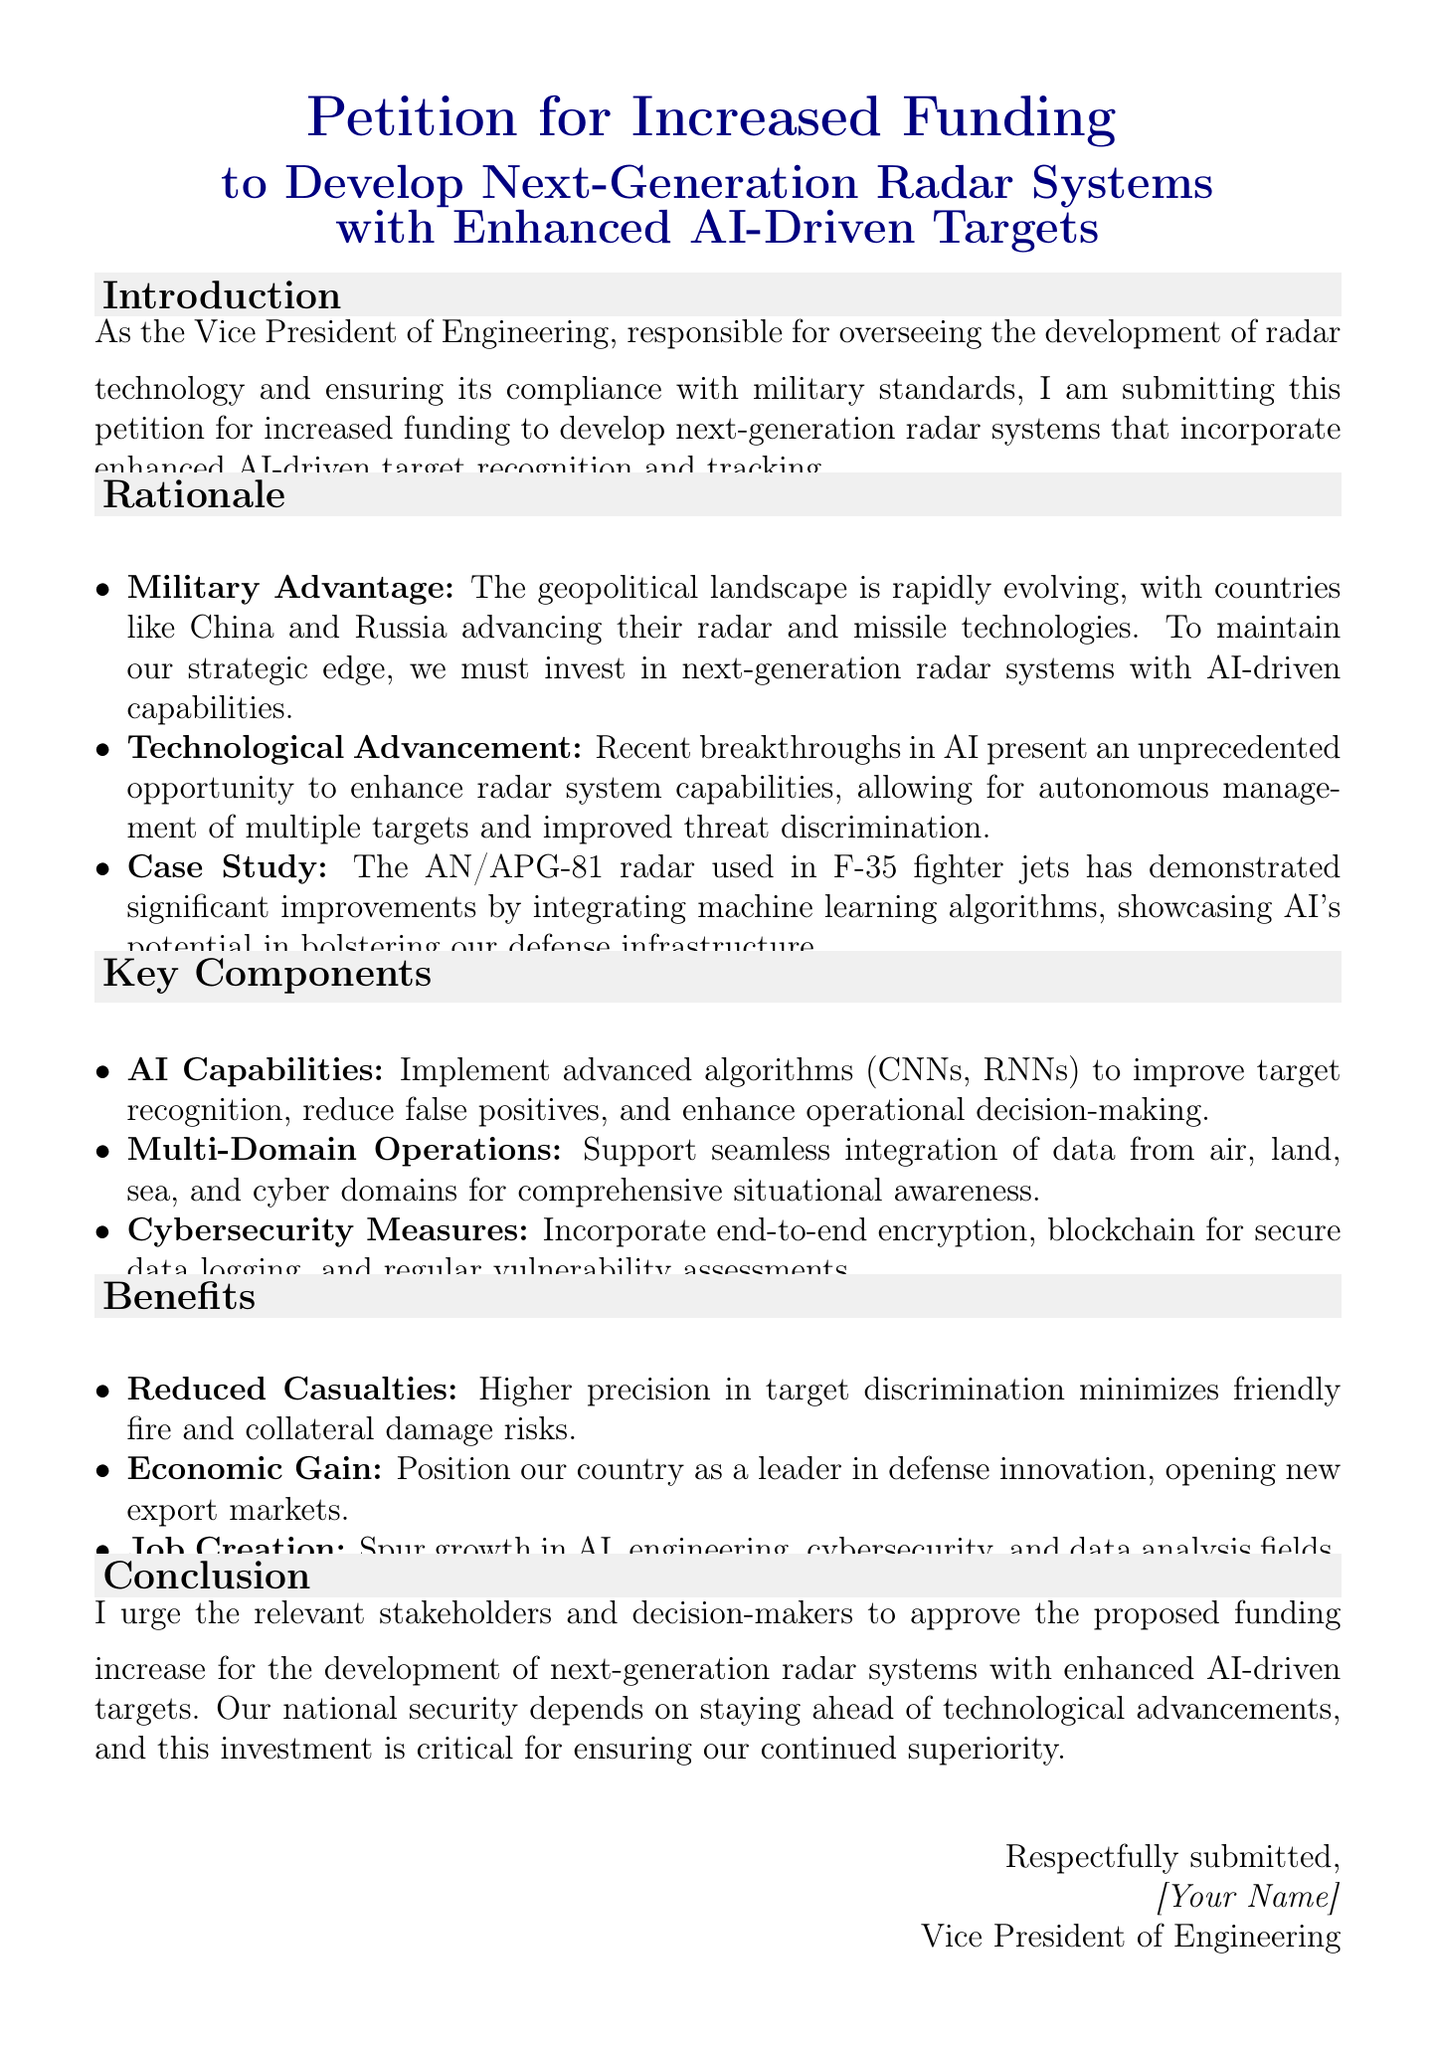What is the title of the petition? The title of the petition is the main heading seen at the top of the document, which encapsulates its purpose.
Answer: Petition for Increased Funding to Develop Next-Generation Radar Systems with Enhanced AI-Driven Targets Who authored the petition? The author of the petition is identified in the closing section, which states their position and name.
Answer: Vice President of Engineering What is one key component mentioned in the document? Key components are listed in the document under a dedicated section, highlighting specific technological aspects.
Answer: AI Capabilities What is a benefit of the proposed radar systems? Benefits are outlined in a section of the document that discusses positive outcomes from the initiative.
Answer: Reduced Casualties Which country is mentioned as advancing its radar technology? The rationale section specifies countries that are progressing in technology, indicating potential threats.
Answer: China What is the case study mentioned in the document? The document provides an example of a specific radar system that illustrates the potential of AI integration in military technology.
Answer: AN/APG-81 radar How many benefits are listed in the document? The document enumerates various benefits in a specific section, which can be counted for clarity.
Answer: Three What is the proposed purpose of the funding increase? The introduction explains the main objective of the petition, giving insight into the desired allocation of resources.
Answer: Develop next-generation radar systems What is one technology mentioned in AI capabilities? The items listed under key components detail the advanced technologies intended for enhancing radar systems.
Answer: CNNs 